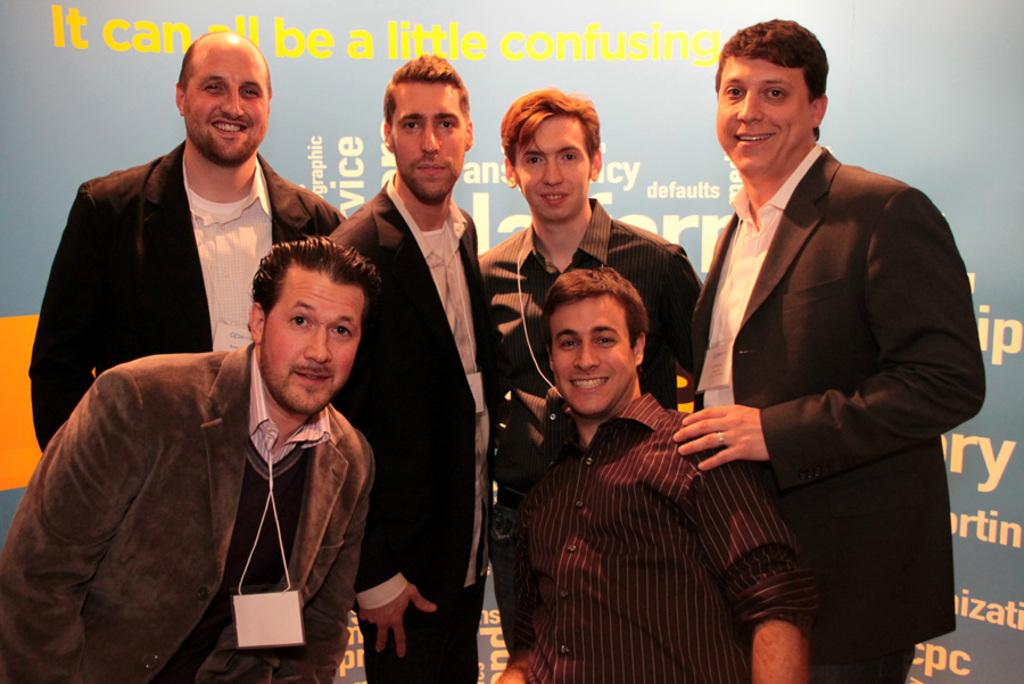Who or what is present in the image? There are people in the image. What is the facial expression of the people in the image? The people are smiling. What can be seen in the background of the image? There is a banner in the background of the image. What is written on the banner? The banner has text on it. What color is the shirt of the person with the name "John" in the image? There is no person named "John" in the image, nor is there any information about their shirt color. 